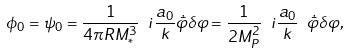<formula> <loc_0><loc_0><loc_500><loc_500>\phi _ { 0 } = \psi _ { 0 } = \frac { 1 } { 4 \pi R M _ { * } ^ { 3 } } \ i \frac { a _ { 0 } } { k } \dot { \bar { \varphi } } \delta \varphi = \frac { 1 } { 2 M _ { P } ^ { 2 } } \ i \frac { a _ { 0 } } { k } \ \dot { \bar { \varphi } } \delta \varphi ,</formula> 